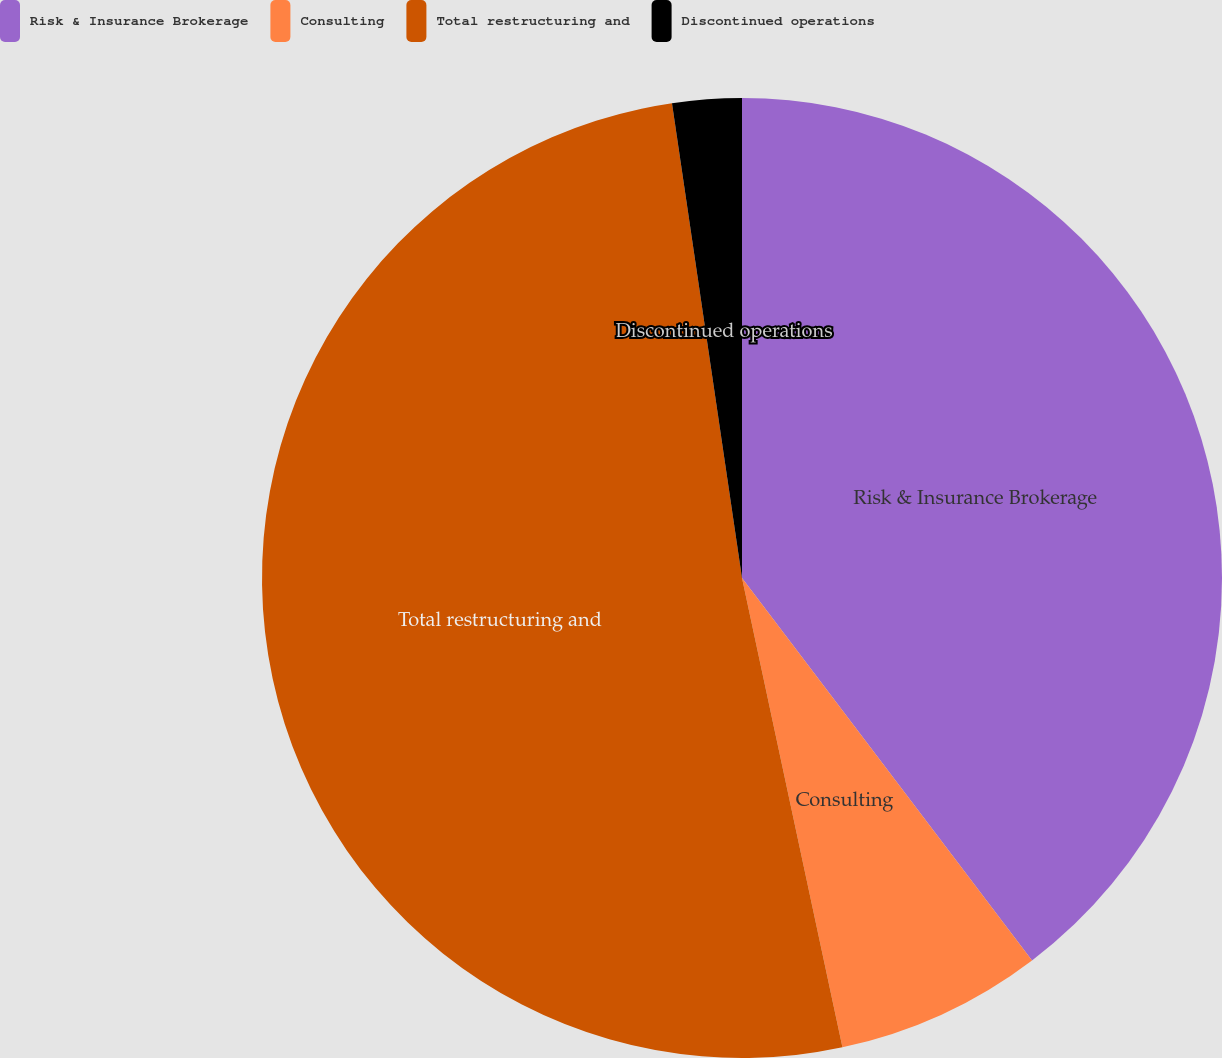Convert chart to OTSL. <chart><loc_0><loc_0><loc_500><loc_500><pie_chart><fcel>Risk & Insurance Brokerage<fcel>Consulting<fcel>Total restructuring and<fcel>Discontinued operations<nl><fcel>39.67%<fcel>6.97%<fcel>51.02%<fcel>2.33%<nl></chart> 